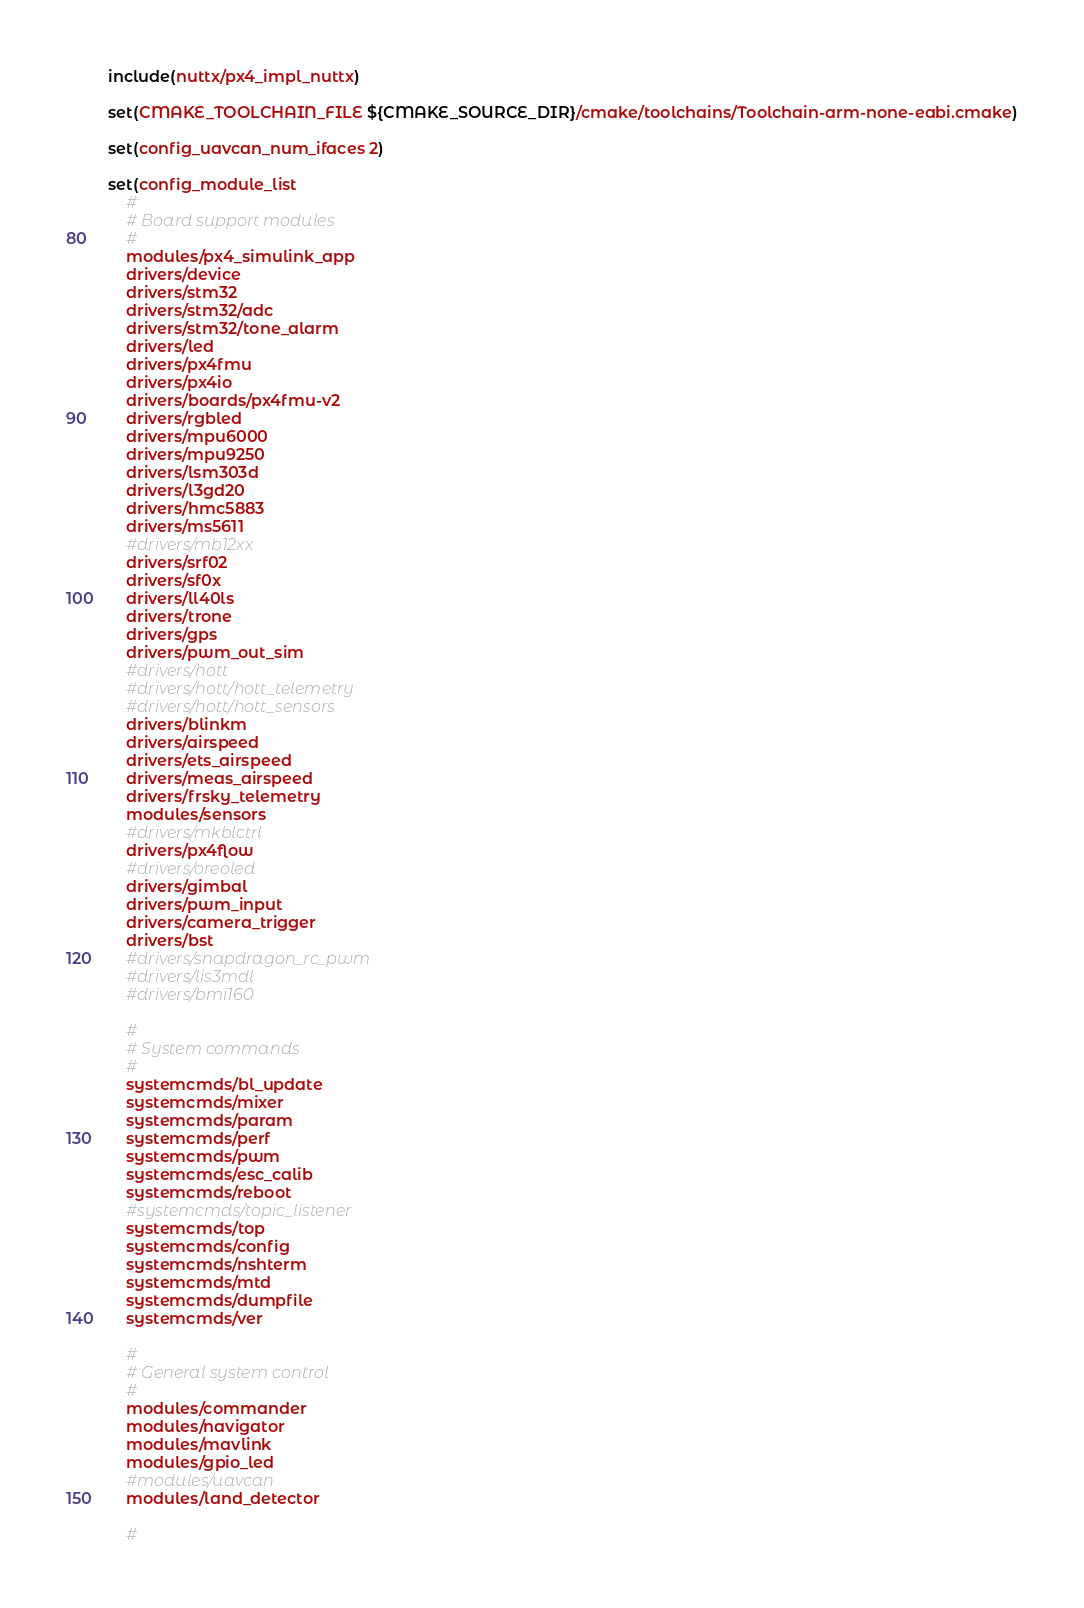<code> <loc_0><loc_0><loc_500><loc_500><_CMake_>include(nuttx/px4_impl_nuttx)

set(CMAKE_TOOLCHAIN_FILE ${CMAKE_SOURCE_DIR}/cmake/toolchains/Toolchain-arm-none-eabi.cmake)

set(config_uavcan_num_ifaces 2)

set(config_module_list
	#
	# Board support modules
	#
	modules/px4_simulink_app
	drivers/device
	drivers/stm32
	drivers/stm32/adc
	drivers/stm32/tone_alarm
	drivers/led
	drivers/px4fmu
	drivers/px4io
	drivers/boards/px4fmu-v2
	drivers/rgbled
	drivers/mpu6000
	drivers/mpu9250
	drivers/lsm303d
	drivers/l3gd20
	drivers/hmc5883
	drivers/ms5611
	#drivers/mb12xx
	drivers/srf02
	drivers/sf0x
	drivers/ll40ls
	drivers/trone
	drivers/gps
	drivers/pwm_out_sim
	#drivers/hott
	#drivers/hott/hott_telemetry
	#drivers/hott/hott_sensors
	drivers/blinkm
	drivers/airspeed
	drivers/ets_airspeed
	drivers/meas_airspeed
	drivers/frsky_telemetry
	modules/sensors
	#drivers/mkblctrl
	drivers/px4flow
	#drivers/oreoled
	drivers/gimbal
	drivers/pwm_input
	drivers/camera_trigger
	drivers/bst
	#drivers/snapdragon_rc_pwm
	#drivers/lis3mdl
	#drivers/bmi160

	#
	# System commands
	#
	systemcmds/bl_update
	systemcmds/mixer
	systemcmds/param
	systemcmds/perf
	systemcmds/pwm
	systemcmds/esc_calib
	systemcmds/reboot
	#systemcmds/topic_listener
	systemcmds/top
	systemcmds/config
	systemcmds/nshterm
	systemcmds/mtd
	systemcmds/dumpfile
	systemcmds/ver

	#
	# General system control
	#
	modules/commander
	modules/navigator
	modules/mavlink
	modules/gpio_led
	#modules/uavcan
	modules/land_detector

	#</code> 